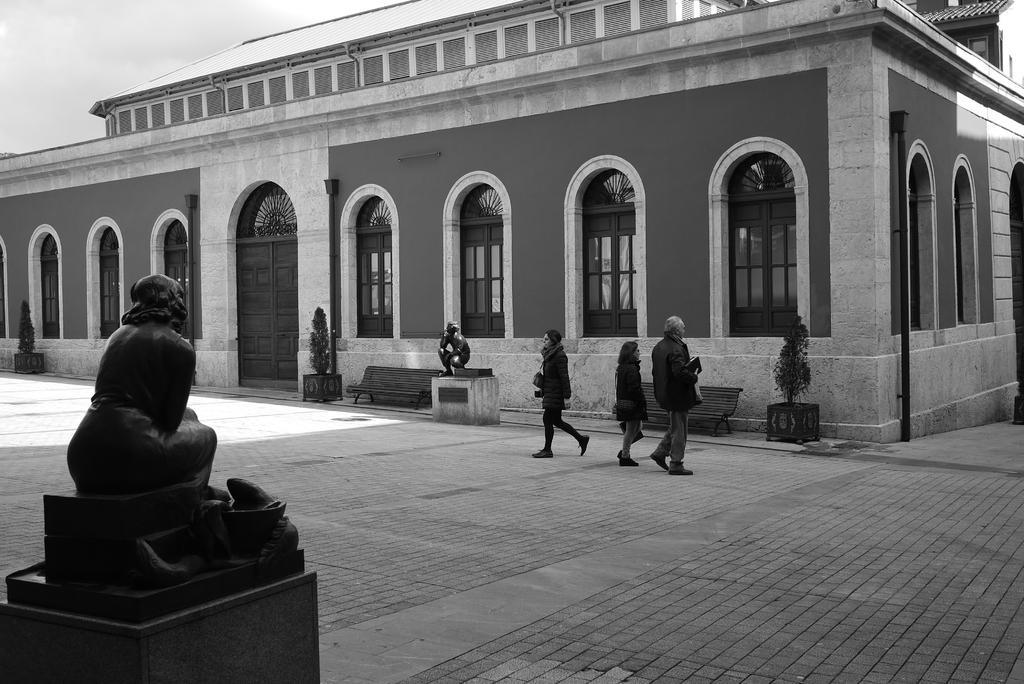Describe this image in one or two sentences. In this image, we can see a house with walls, windows and doors. Here we can see plants, benches, pole and statues. In the middle of the image, we can see three people are walking on the platform. Background there is a sky. 